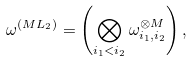Convert formula to latex. <formula><loc_0><loc_0><loc_500><loc_500>\omega ^ { ( M L _ { 2 } ) } = \left ( \bigotimes _ { i _ { 1 } < i _ { 2 } } \omega _ { i _ { 1 } , i _ { 2 } } ^ { \otimes M } \right ) ,</formula> 